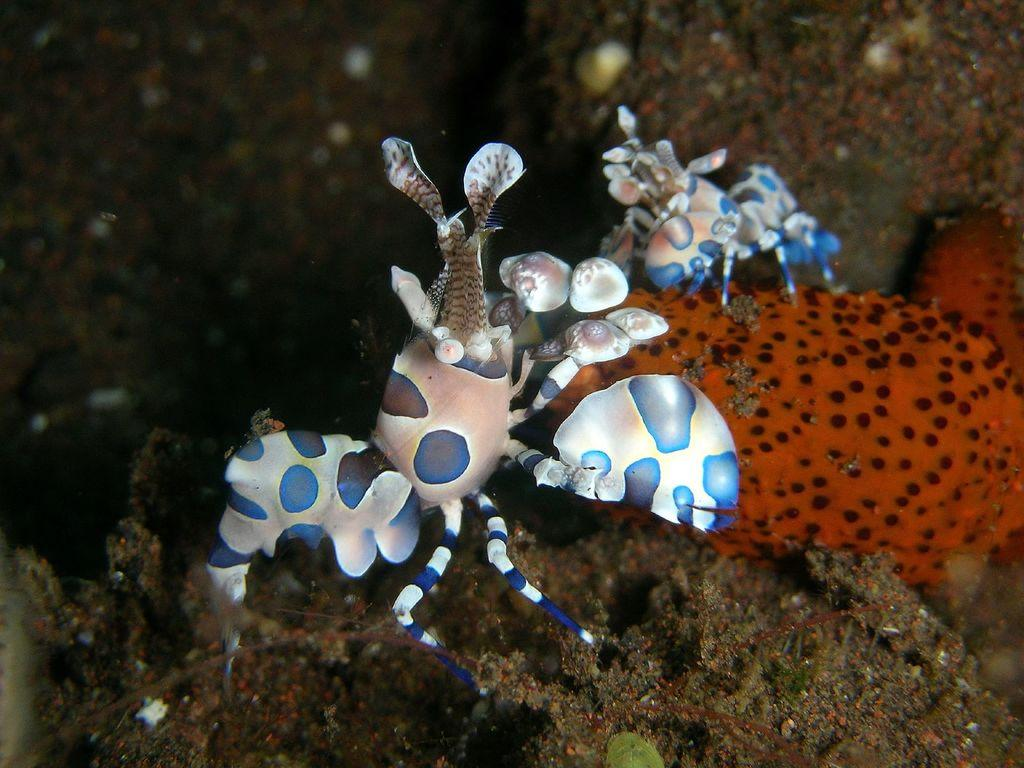How many animals are present in the image? There are two animals in the image. Can you describe the colors of the animals? One animal is white and the other is blue. What else can be seen in the image besides the animals? There is a red and black color thing in the image. How would you describe the background of the image? The background of the image is blurred. How does the minute adjust the stretch in the image? There is no minute or stretch present in the image; it features two animals and a red and black color thing with a blurred background. 